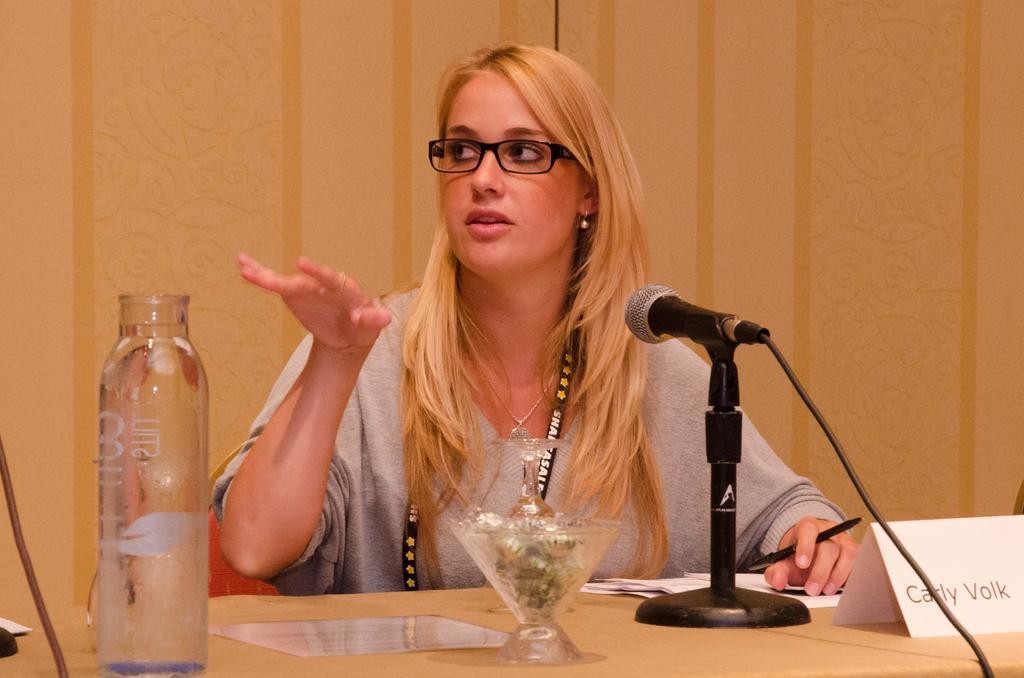In one or two sentences, can you explain what this image depicts? This picture shows a woman looking at someone else and is a microphone in front of her 